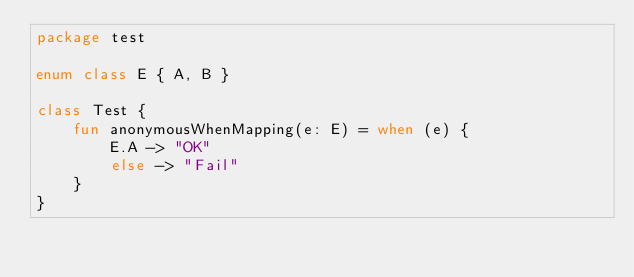Convert code to text. <code><loc_0><loc_0><loc_500><loc_500><_Kotlin_>package test

enum class E { A, B }

class Test {
    fun anonymousWhenMapping(e: E) = when (e) {
        E.A -> "OK"
        else -> "Fail"
    }
}
</code> 